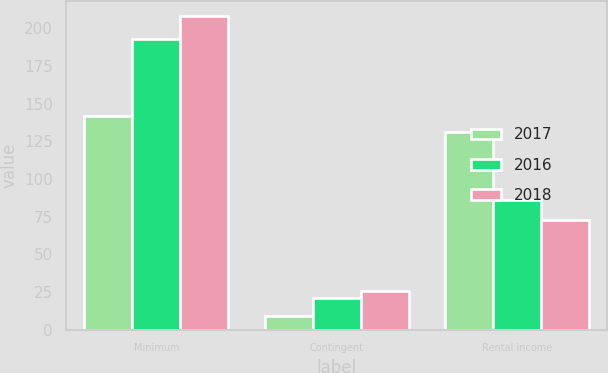Convert chart. <chart><loc_0><loc_0><loc_500><loc_500><stacked_bar_chart><ecel><fcel>Minimum<fcel>Contingent<fcel>Rental income<nl><fcel>2017<fcel>142<fcel>9<fcel>131<nl><fcel>2016<fcel>193<fcel>21<fcel>86<nl><fcel>2018<fcel>208<fcel>26<fcel>73<nl></chart> 